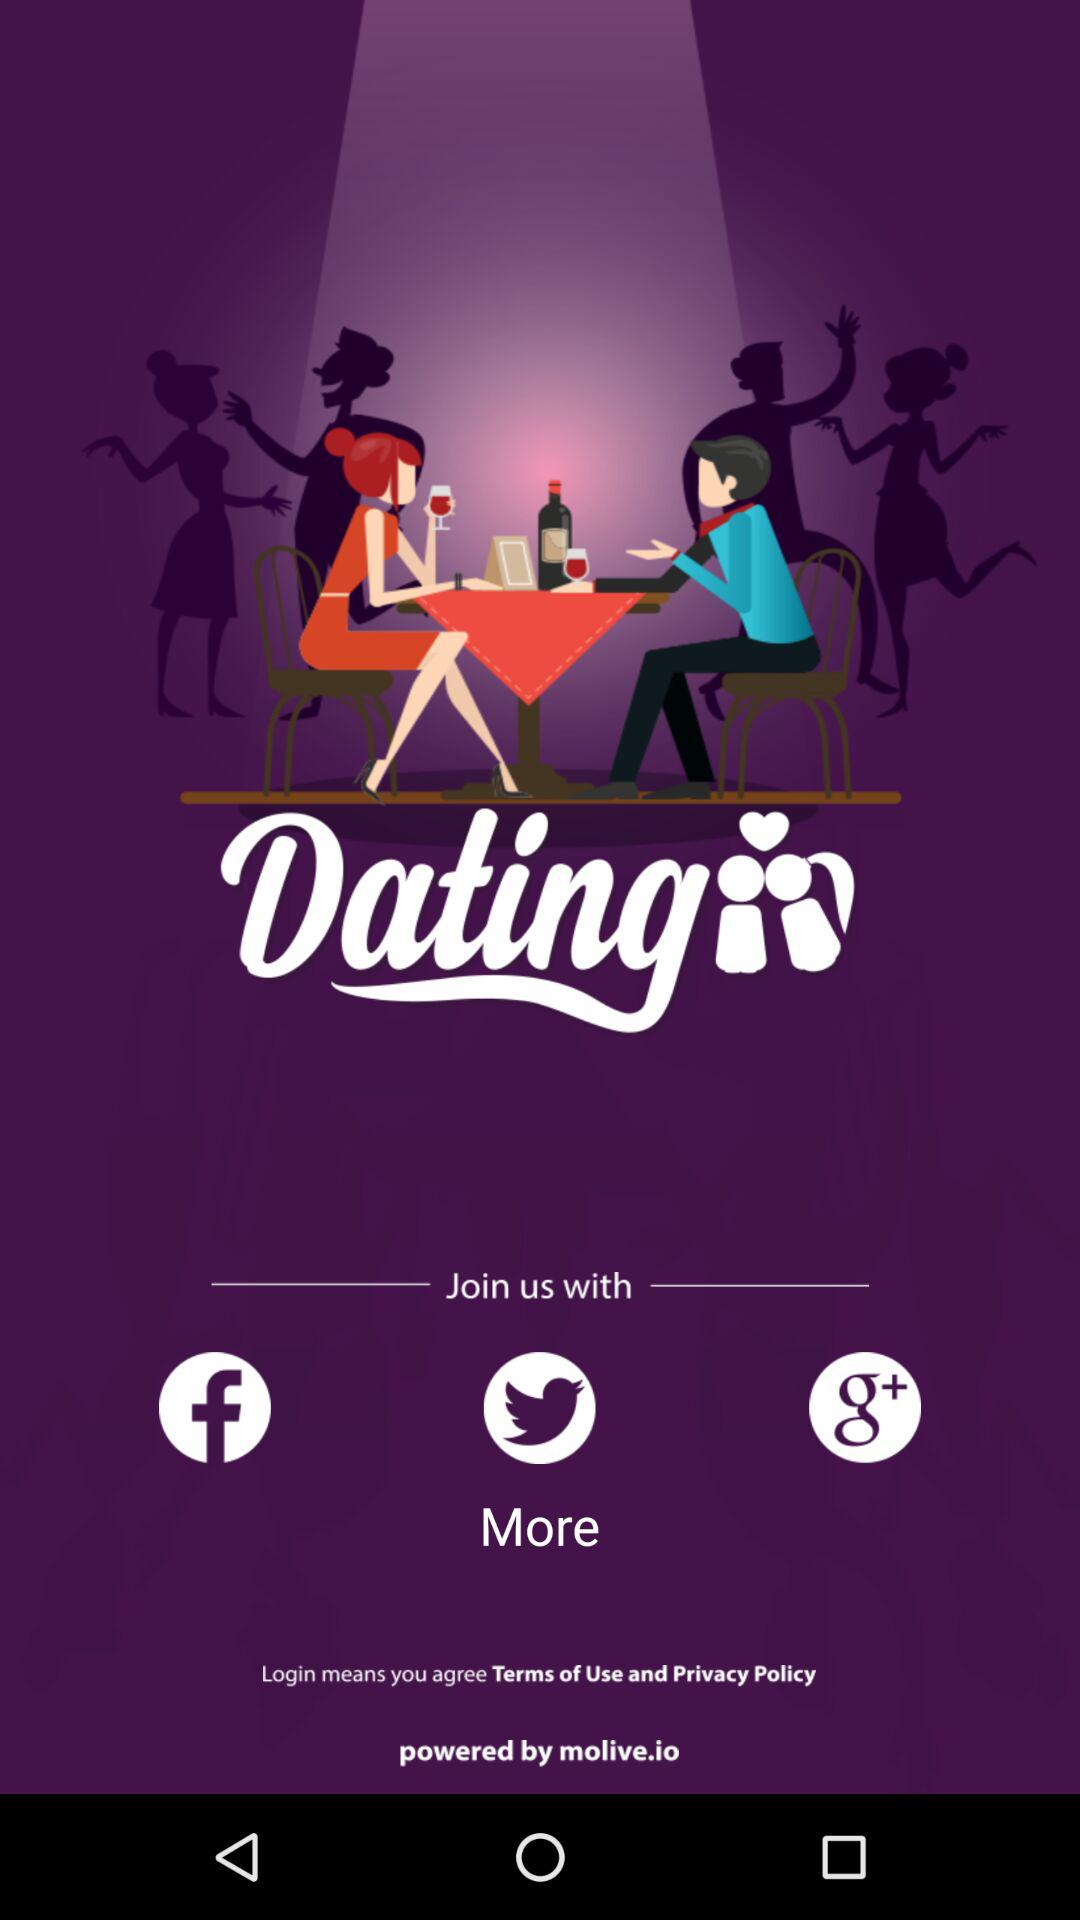What is the app name? The app name is "Dating". 